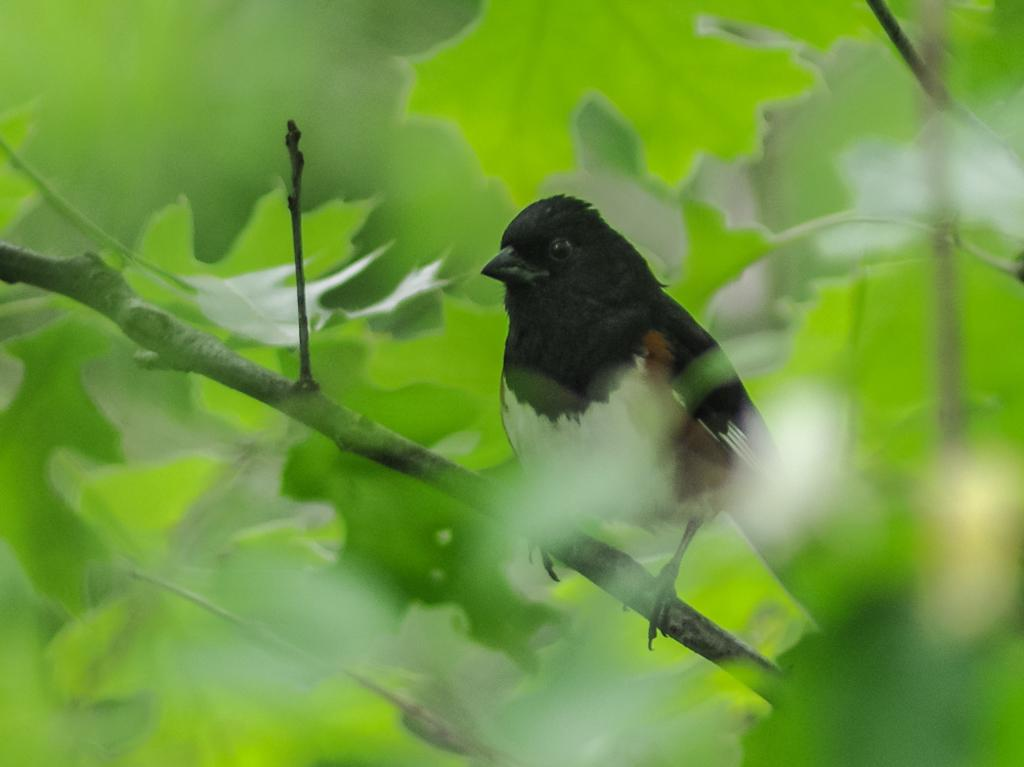What type of animal is in the image? There is a bird in the image. Where is the bird located? The bird is on a stem. What colors can be seen on the bird? The bird has white, black, and brown colors. What can be seen in the background of the image? There are trees in the background of the image, but they are blurry. What type of machine is the bird using to fly in the image? There is no machine present in the image; the bird is naturally flying on the stem. 